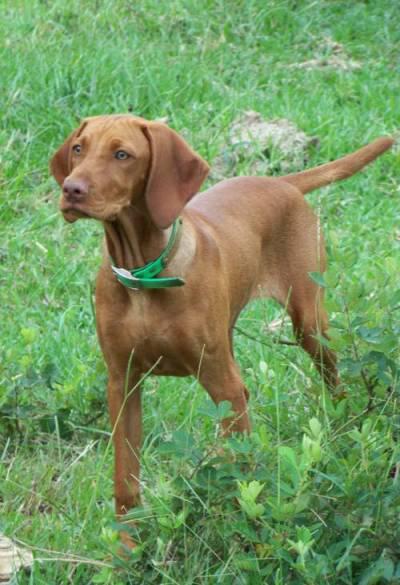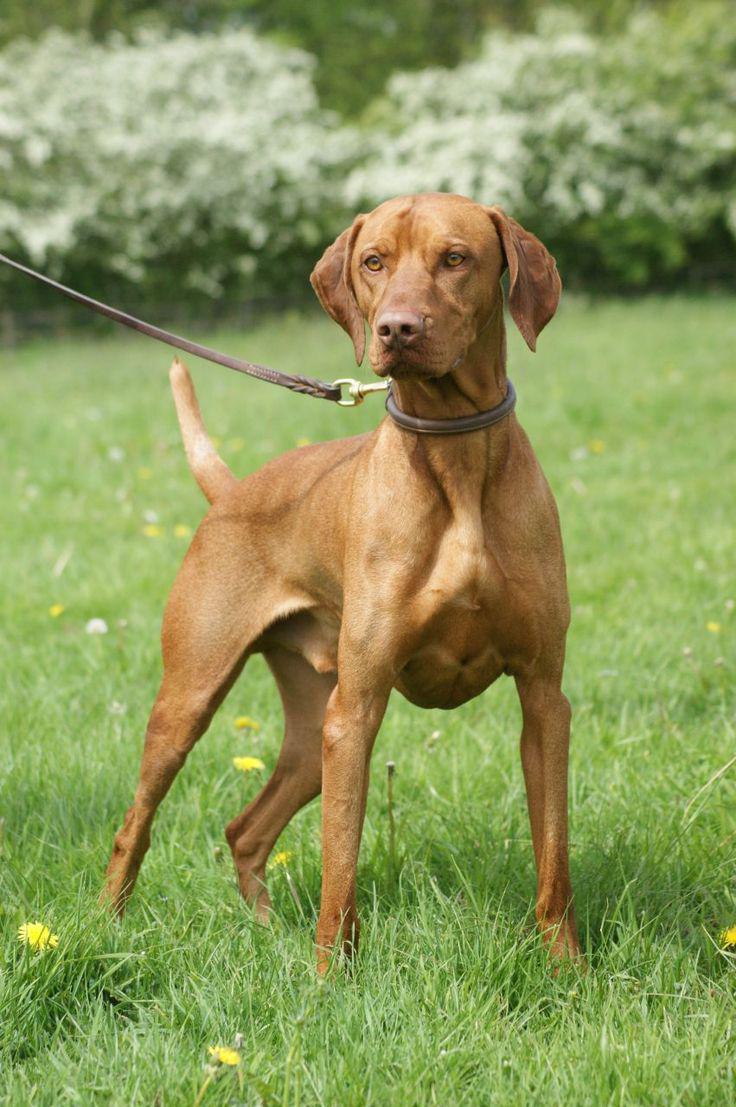The first image is the image on the left, the second image is the image on the right. Evaluate the accuracy of this statement regarding the images: "One image shows a dog standing in profile with its body turned leftward, and the other image shows a dog standing with its body turned rightward and with one front paw raised.". Is it true? Answer yes or no. No. The first image is the image on the left, the second image is the image on the right. Considering the images on both sides, is "The dog in the image on the right is on a leash." valid? Answer yes or no. Yes. 